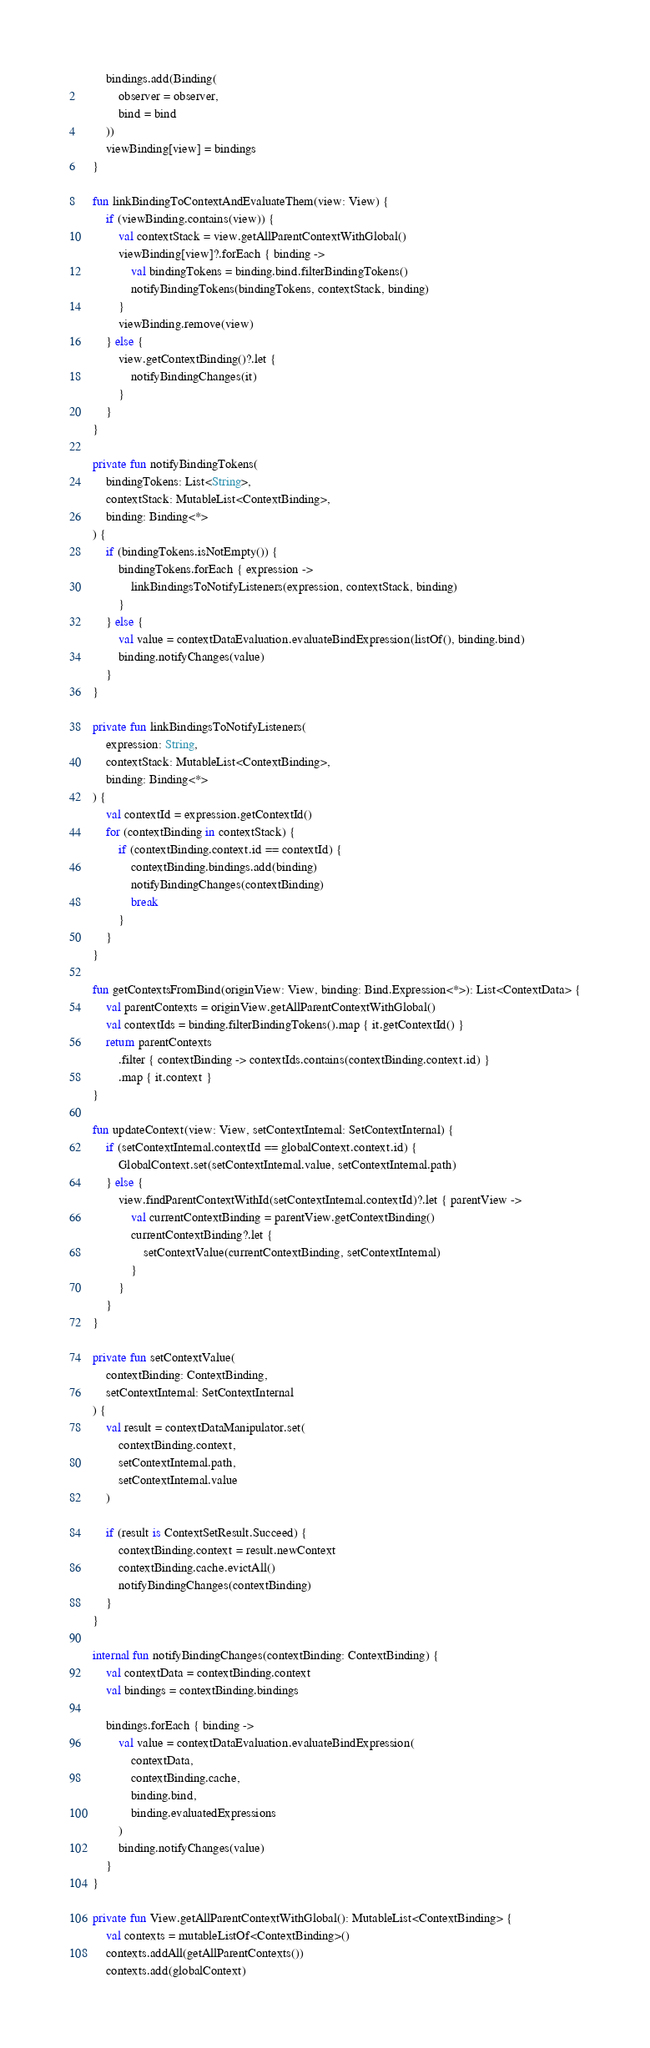Convert code to text. <code><loc_0><loc_0><loc_500><loc_500><_Kotlin_>        bindings.add(Binding(
            observer = observer,
            bind = bind
        ))
        viewBinding[view] = bindings
    }

    fun linkBindingToContextAndEvaluateThem(view: View) {
        if (viewBinding.contains(view)) {
            val contextStack = view.getAllParentContextWithGlobal()
            viewBinding[view]?.forEach { binding ->
                val bindingTokens = binding.bind.filterBindingTokens()
                notifyBindingTokens(bindingTokens, contextStack, binding)
            }
            viewBinding.remove(view)
        } else {
            view.getContextBinding()?.let {
                notifyBindingChanges(it)
            }
        }
    }

    private fun notifyBindingTokens(
        bindingTokens: List<String>,
        contextStack: MutableList<ContextBinding>,
        binding: Binding<*>
    ) {
        if (bindingTokens.isNotEmpty()) {
            bindingTokens.forEach { expression ->
                linkBindingsToNotifyListeners(expression, contextStack, binding)
            }
        } else {
            val value = contextDataEvaluation.evaluateBindExpression(listOf(), binding.bind)
            binding.notifyChanges(value)
        }
    }

    private fun linkBindingsToNotifyListeners(
        expression: String,
        contextStack: MutableList<ContextBinding>,
        binding: Binding<*>
    ) {
        val contextId = expression.getContextId()
        for (contextBinding in contextStack) {
            if (contextBinding.context.id == contextId) {
                contextBinding.bindings.add(binding)
                notifyBindingChanges(contextBinding)
                break
            }
        }
    }

    fun getContextsFromBind(originView: View, binding: Bind.Expression<*>): List<ContextData> {
        val parentContexts = originView.getAllParentContextWithGlobal()
        val contextIds = binding.filterBindingTokens().map { it.getContextId() }
        return parentContexts
            .filter { contextBinding -> contextIds.contains(contextBinding.context.id) }
            .map { it.context }
    }

    fun updateContext(view: View, setContextInternal: SetContextInternal) {
        if (setContextInternal.contextId == globalContext.context.id) {
            GlobalContext.set(setContextInternal.value, setContextInternal.path)
        } else {
            view.findParentContextWithId(setContextInternal.contextId)?.let { parentView ->
                val currentContextBinding = parentView.getContextBinding()
                currentContextBinding?.let {
                    setContextValue(currentContextBinding, setContextInternal)
                }
            }
        }
    }

    private fun setContextValue(
        contextBinding: ContextBinding,
        setContextInternal: SetContextInternal
    ) {
        val result = contextDataManipulator.set(
            contextBinding.context,
            setContextInternal.path,
            setContextInternal.value
        )

        if (result is ContextSetResult.Succeed) {
            contextBinding.context = result.newContext
            contextBinding.cache.evictAll()
            notifyBindingChanges(contextBinding)
        }
    }

    internal fun notifyBindingChanges(contextBinding: ContextBinding) {
        val contextData = contextBinding.context
        val bindings = contextBinding.bindings

        bindings.forEach { binding ->
            val value = contextDataEvaluation.evaluateBindExpression(
                contextData,
                contextBinding.cache,
                binding.bind,
                binding.evaluatedExpressions
            )
            binding.notifyChanges(value)
        }
    }

    private fun View.getAllParentContextWithGlobal(): MutableList<ContextBinding> {
        val contexts = mutableListOf<ContextBinding>()
        contexts.addAll(getAllParentContexts())
        contexts.add(globalContext)</code> 